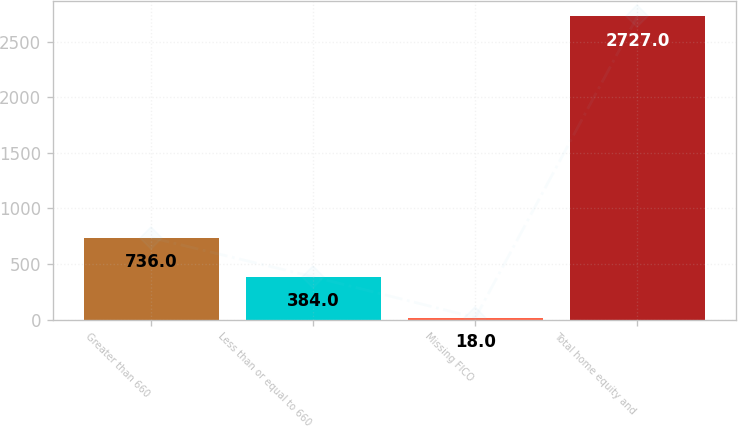Convert chart. <chart><loc_0><loc_0><loc_500><loc_500><bar_chart><fcel>Greater than 660<fcel>Less than or equal to 660<fcel>Missing FICO<fcel>Total home equity and<nl><fcel>736<fcel>384<fcel>18<fcel>2727<nl></chart> 